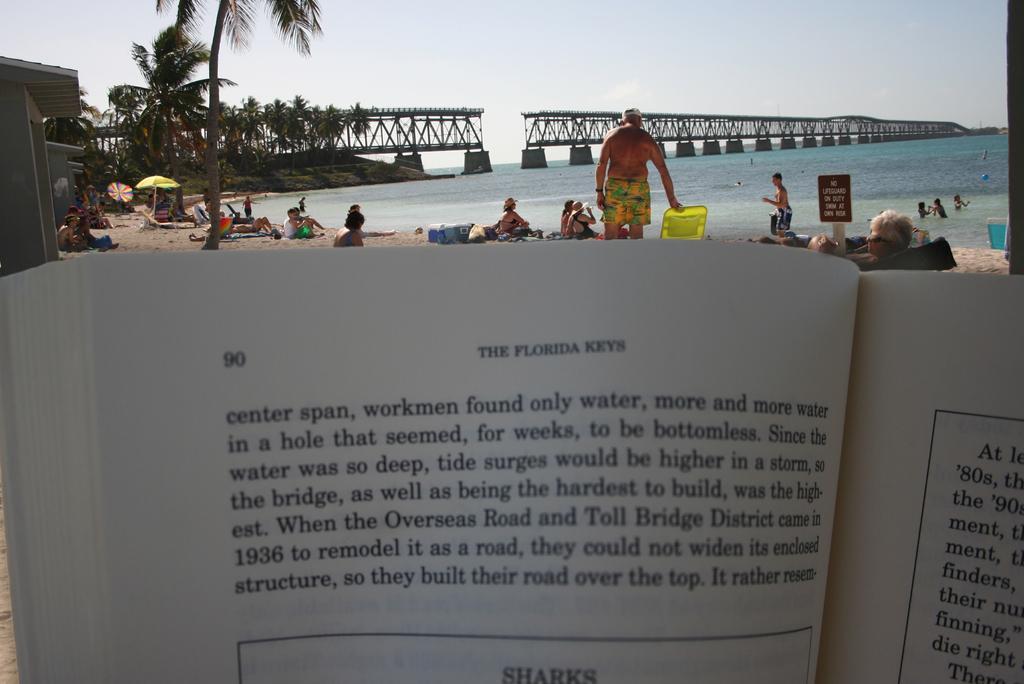In one or two sentences, can you explain what this image depicts? In the center of the image we can see some persons, trees, tent, containers, boards, chairs are there. In the middle of the image a bridge is present. At the top of the image sky is there. On the right side of the image water is there. At the bottom of the image book is there. On book some text is present. 